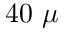<formula> <loc_0><loc_0><loc_500><loc_500>4 0 \ \mu</formula> 